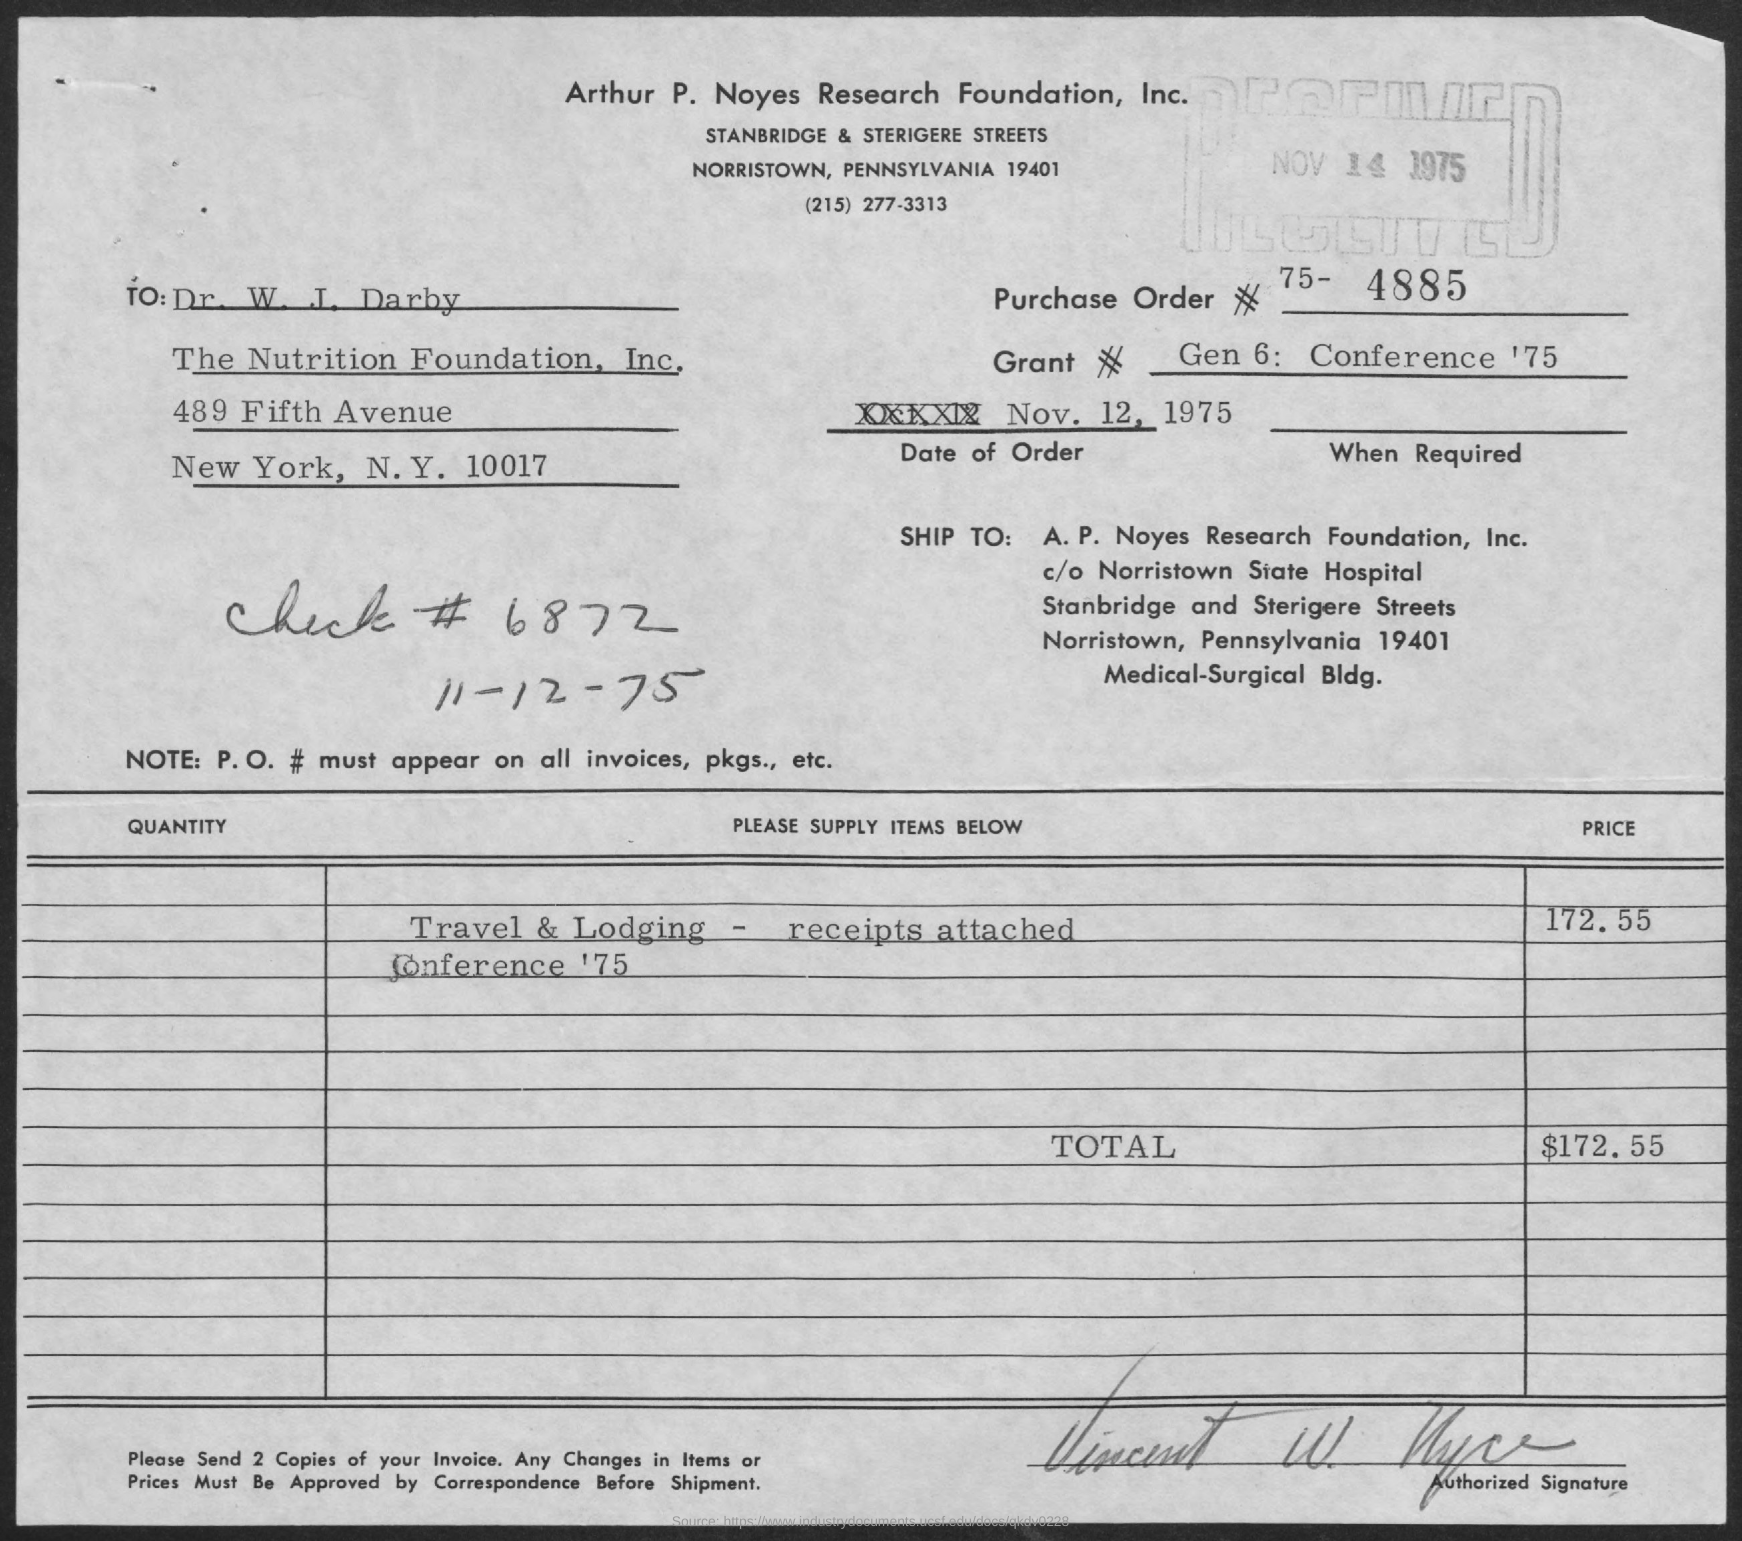Specify some key components in this picture. The invoice amount as per the document is $172.55. The grant number mentioned in this document is Grant #(no), which was given in 1975 at a conference called "Gen 6. The document includes a reference to "Check #(no)." The number 6872 is also mentioned in the document. The date of the order mentioned in this document is November 12, 1975. 